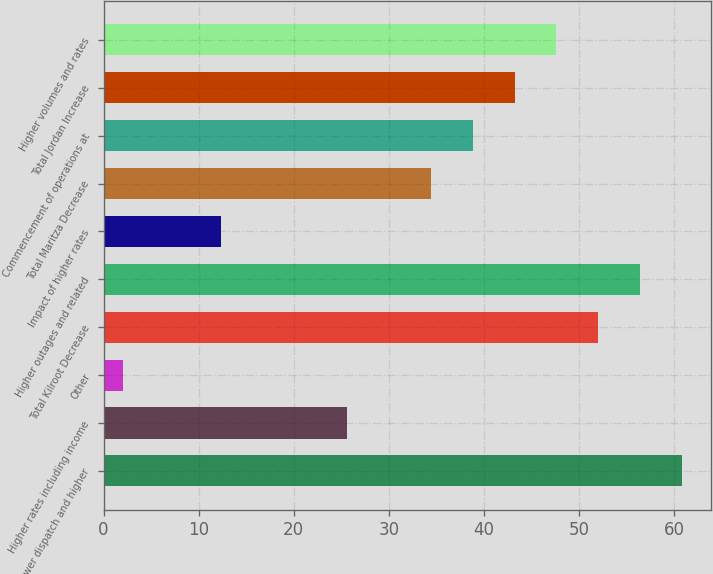<chart> <loc_0><loc_0><loc_500><loc_500><bar_chart><fcel>Lower dispatch and higher<fcel>Higher rates including income<fcel>Other<fcel>Total Kilroot Decrease<fcel>Higher outages and related<fcel>Impact of higher rates<fcel>Total Maritza Decrease<fcel>Commencement of operations at<fcel>Total Jordan Increase<fcel>Higher volumes and rates<nl><fcel>60.8<fcel>25.6<fcel>2<fcel>52<fcel>56.4<fcel>12.4<fcel>34.4<fcel>38.8<fcel>43.2<fcel>47.6<nl></chart> 